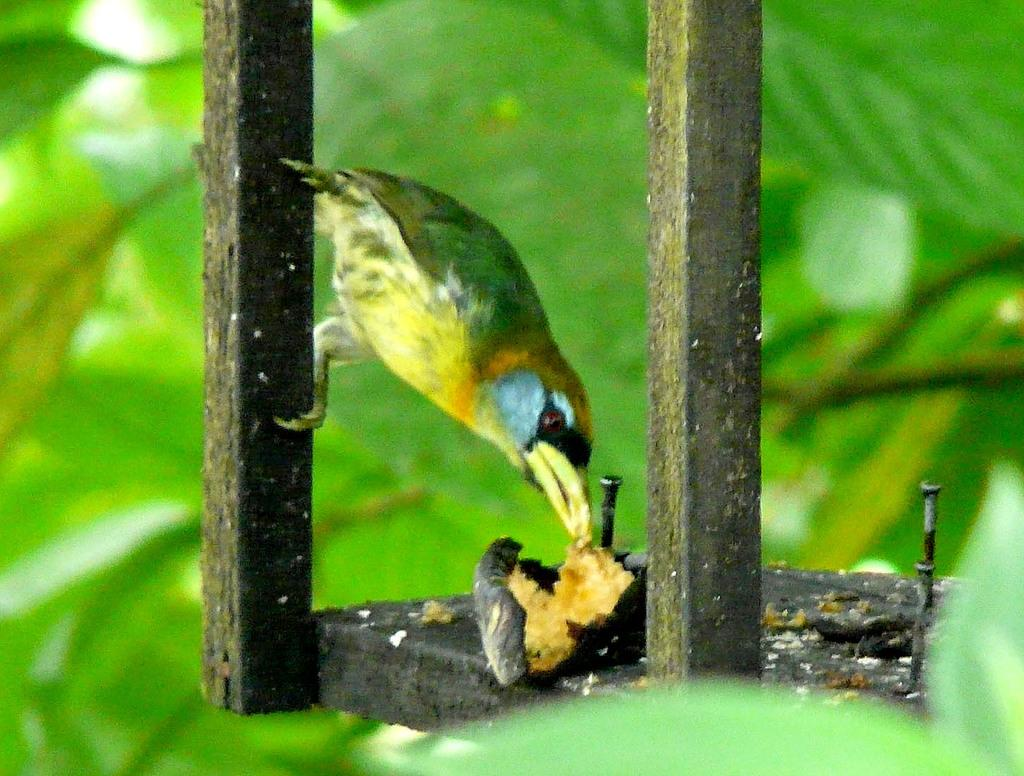What type of animal is in the image? There is a bird in the image. Where is the bird located? The bird is on a wooden object. What can be inferred about the surroundings from the background of the image? The background of the image is green, indicating greenery. What type of thread is being used by the bird in the image? There is no thread present in the image, and the bird is not shown using any thread. 